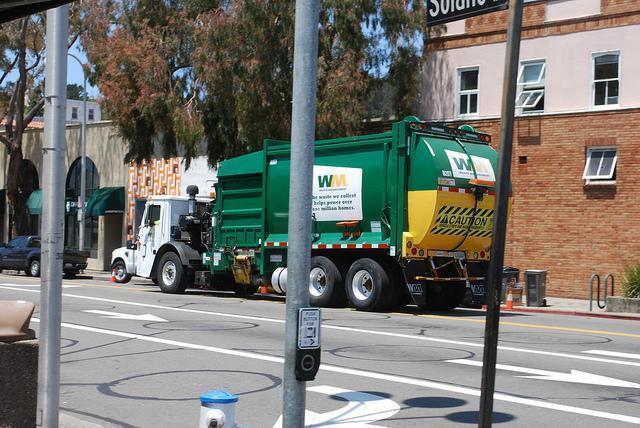What kind of product is likely hauled by the green truck?
Select the accurate response from the four choices given to answer the question.
Options: Furniture, electronics, waste, wood. Waste. 